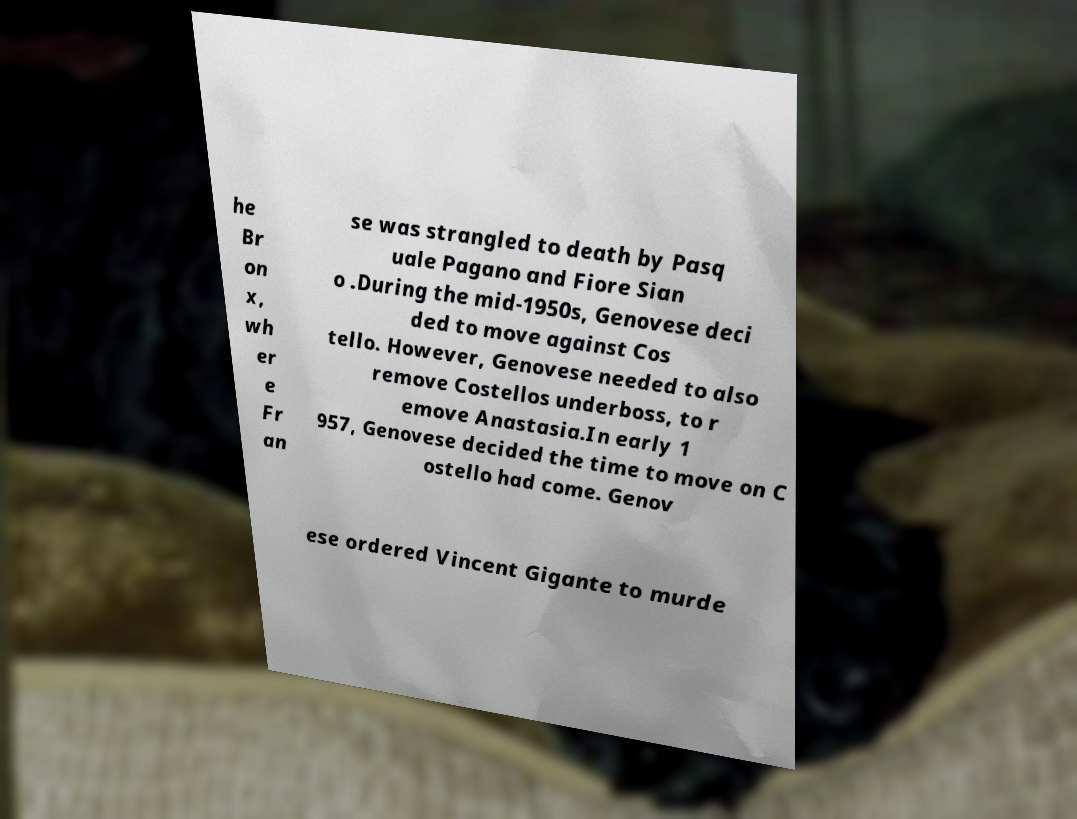Please read and relay the text visible in this image. What does it say? he Br on x, wh er e Fr an se was strangled to death by Pasq uale Pagano and Fiore Sian o .During the mid-1950s, Genovese deci ded to move against Cos tello. However, Genovese needed to also remove Costellos underboss, to r emove Anastasia.In early 1 957, Genovese decided the time to move on C ostello had come. Genov ese ordered Vincent Gigante to murde 